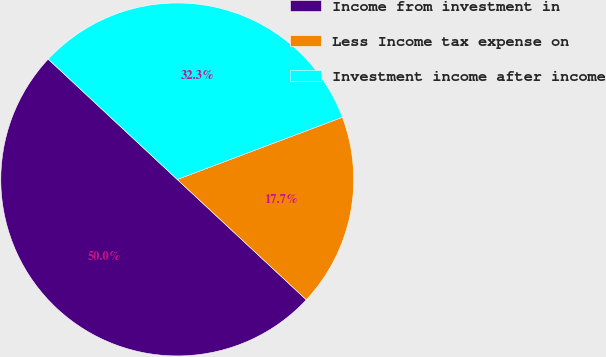<chart> <loc_0><loc_0><loc_500><loc_500><pie_chart><fcel>Income from investment in<fcel>Less Income tax expense on<fcel>Investment income after income<nl><fcel>50.0%<fcel>17.68%<fcel>32.32%<nl></chart> 